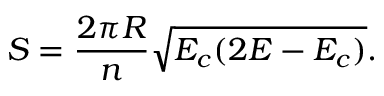Convert formula to latex. <formula><loc_0><loc_0><loc_500><loc_500>S = \frac { 2 \pi R } { n } \sqrt { E _ { c } ( 2 E - E _ { c } ) } .</formula> 